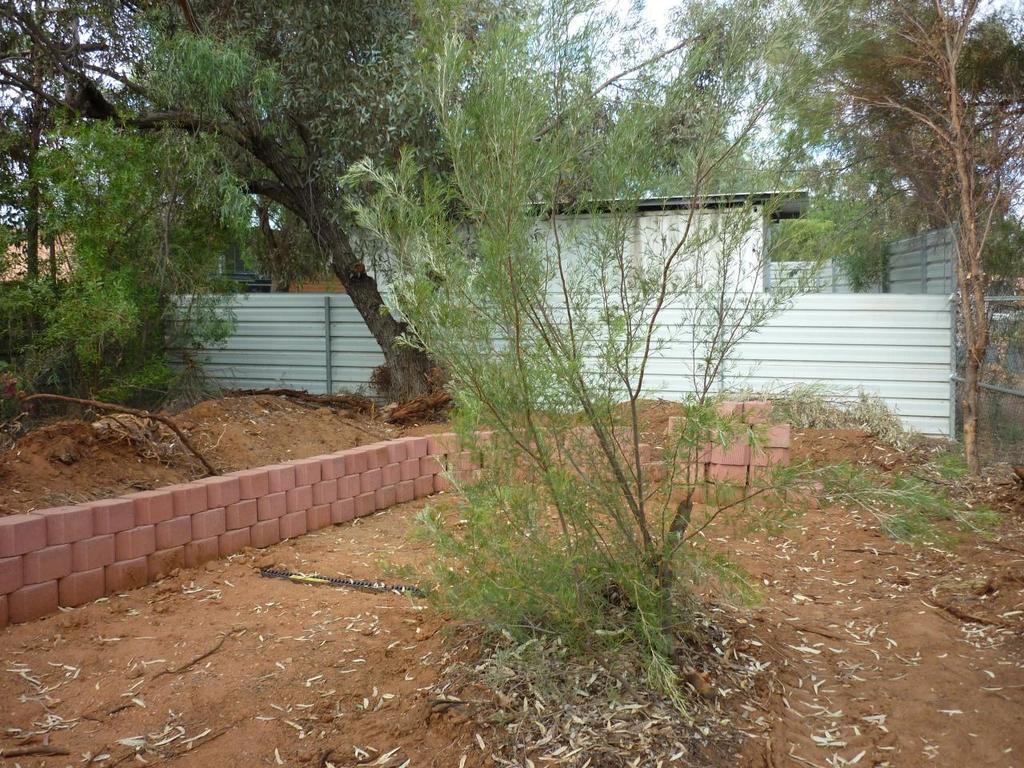What type of vegetation can be seen in the image? There are plants in the image. What is the material of the wall in the image? The wall in the image has bricks. What type of fence is present in the image? There is a metal fence in the image. What type of structure can be seen in the image? There is a building in the image. What type of natural feature is visible in the image? There is a group of trees in the image. What is the condition of the sky in the image? The sky is visible and appears cloudy in the image. What is the temperature of the jelly in the image? There is no jelly present in the image. How does the low battery affect the plants in the image? There is no mention of a low battery or any electronic device in the image, so it cannot affect the plants. 